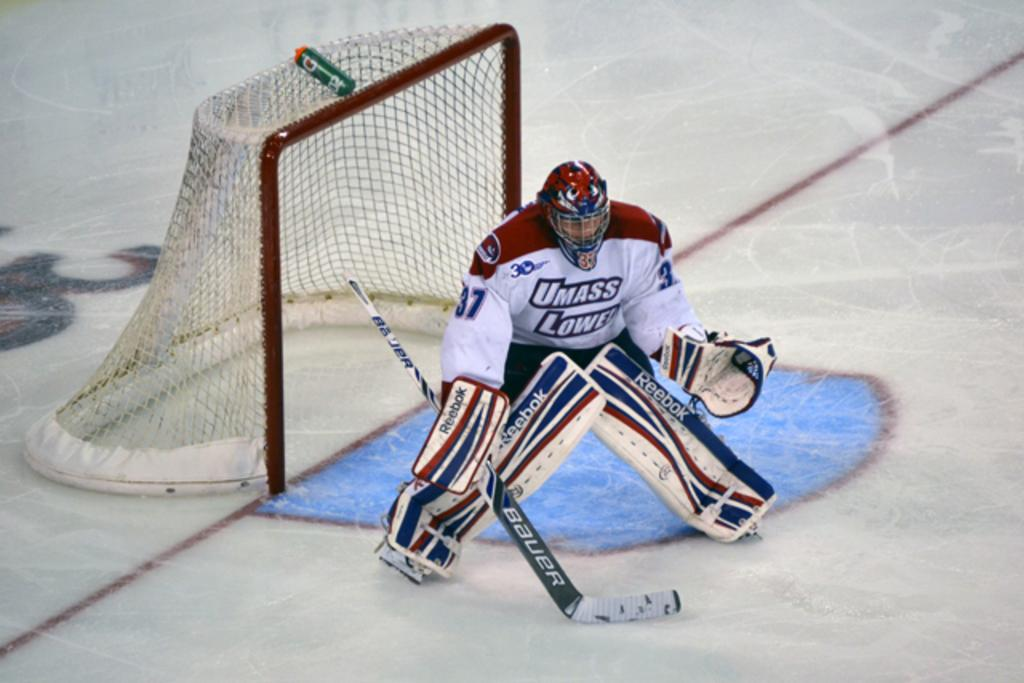What is the main subject in the foreground of the image? There is a man standing in the foreground of the image. What protective gear is the man wearing? The man is wearing gloves and knee pads. What object is the man holding in the image? The man is holding a hockey bat. What type of surface is the man standing on? The man is standing on an ice surface. What is located behind the man in the image? There is a goal net behind the man. What type of veil is draped over the hockey bat in the image? There is no veil present in the image; the man is holding a hockey bat without any additional coverings. 